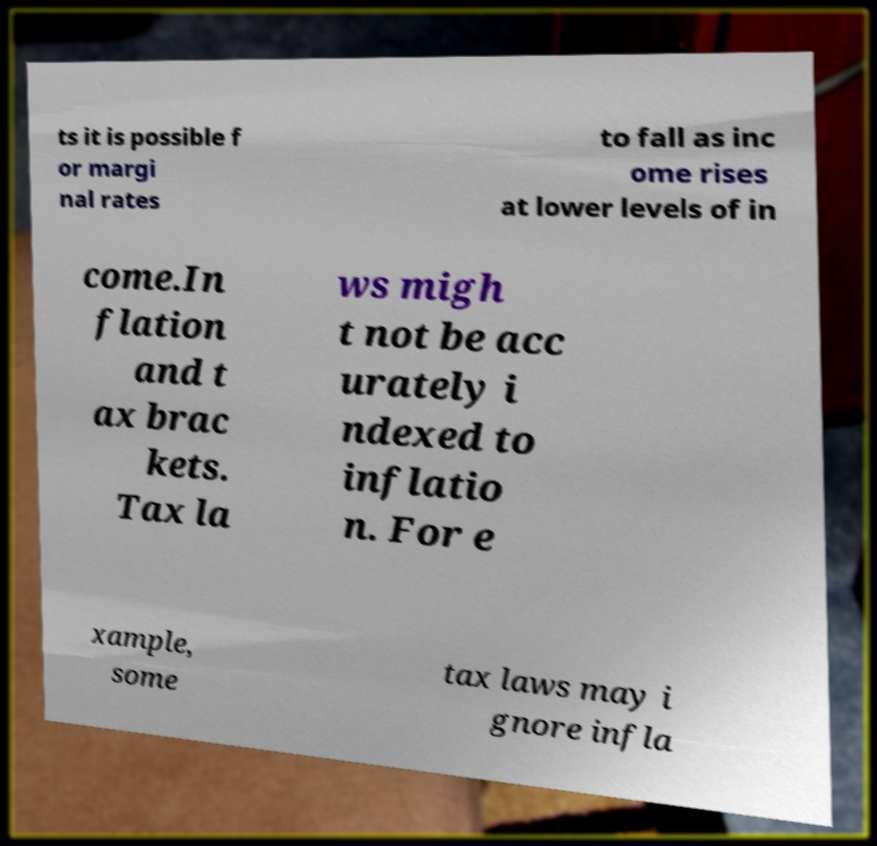Can you accurately transcribe the text from the provided image for me? ts it is possible f or margi nal rates to fall as inc ome rises at lower levels of in come.In flation and t ax brac kets. Tax la ws migh t not be acc urately i ndexed to inflatio n. For e xample, some tax laws may i gnore infla 